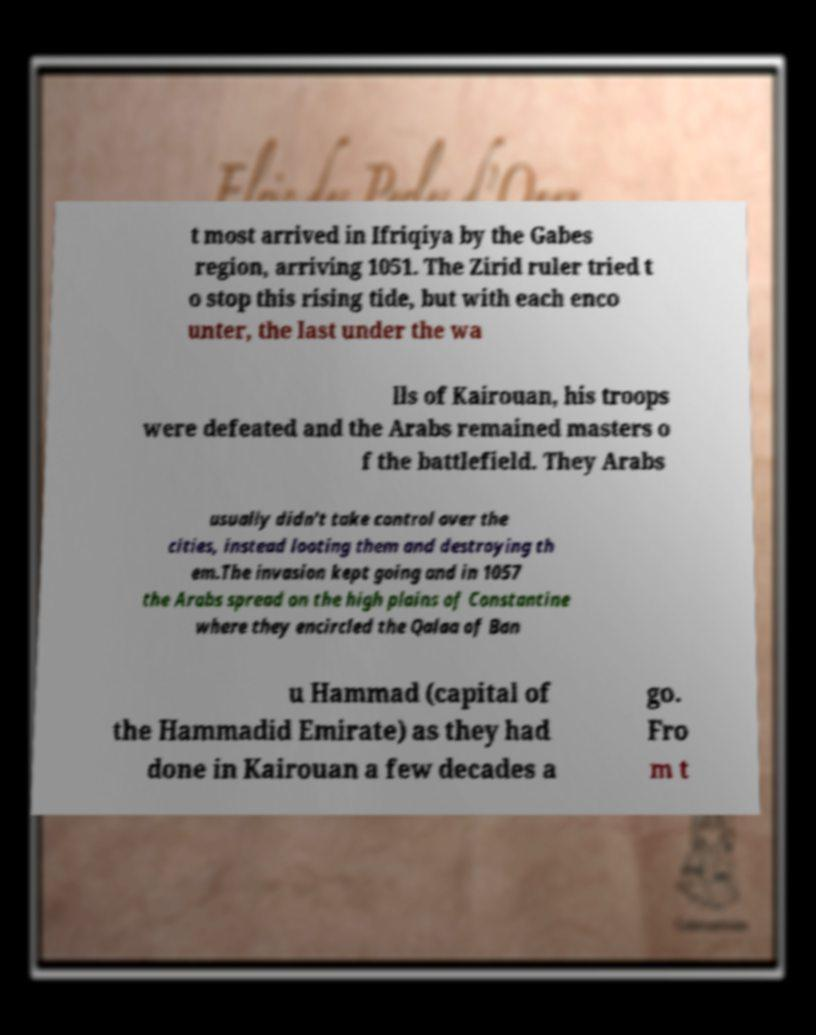For documentation purposes, I need the text within this image transcribed. Could you provide that? t most arrived in Ifriqiya by the Gabes region, arriving 1051. The Zirid ruler tried t o stop this rising tide, but with each enco unter, the last under the wa lls of Kairouan, his troops were defeated and the Arabs remained masters o f the battlefield. They Arabs usually didn't take control over the cities, instead looting them and destroying th em.The invasion kept going and in 1057 the Arabs spread on the high plains of Constantine where they encircled the Qalaa of Ban u Hammad (capital of the Hammadid Emirate) as they had done in Kairouan a few decades a go. Fro m t 